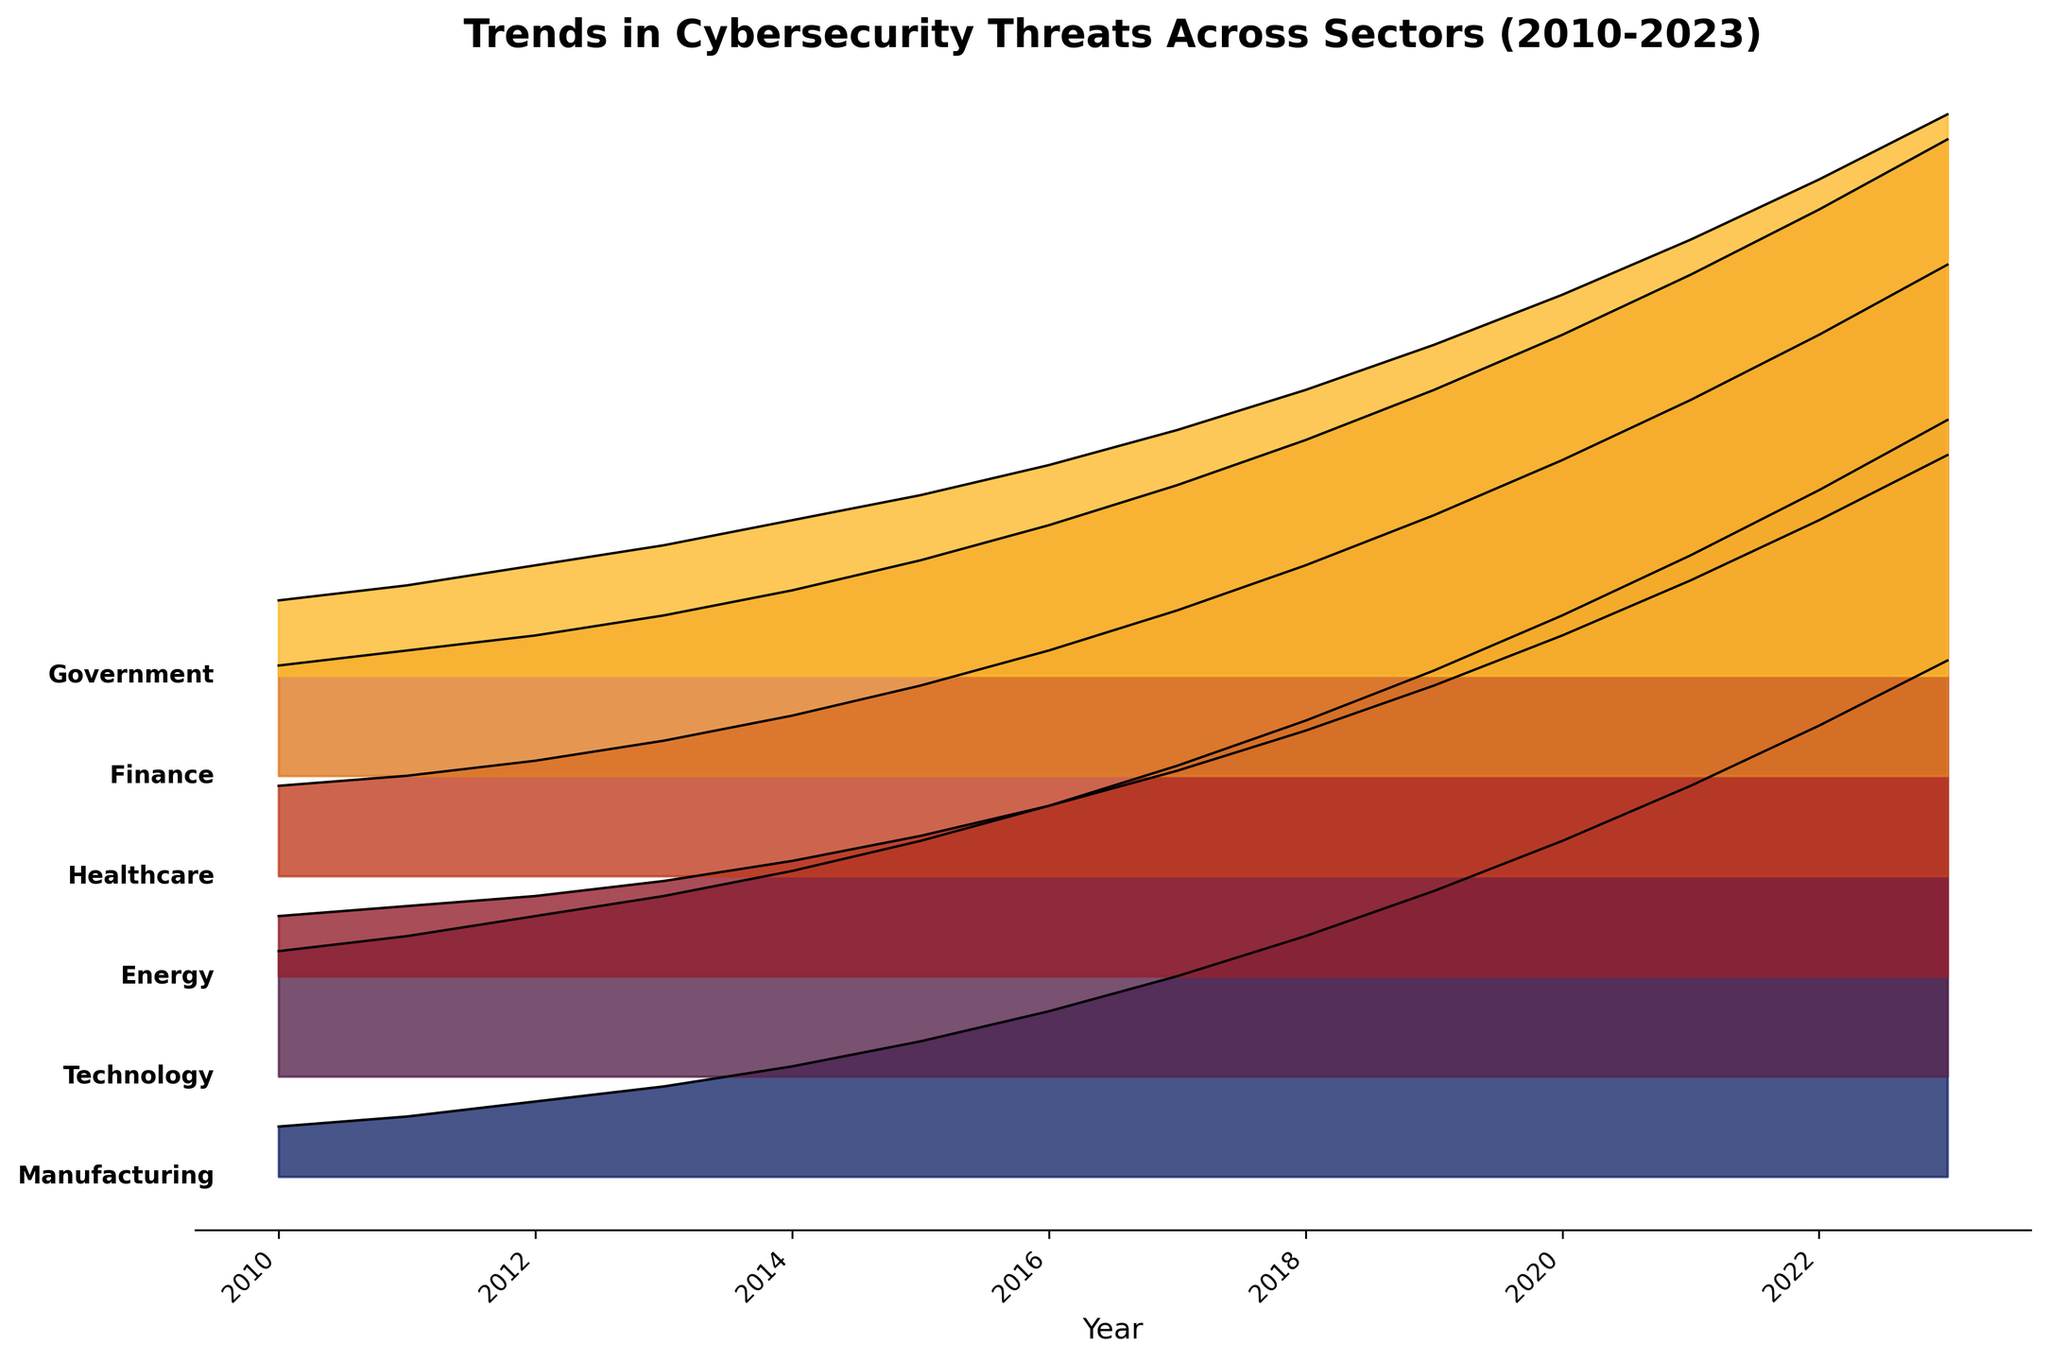What is the title of the plot? The title is usually the text written at the top of the plot. Here, the title is written in bold and larger font compared to the other text.
Answer: Trends in Cybersecurity Threats Across Sectors (2010-2023) Which sector experienced the highest number of cybersecurity threats in 2023? Look for the sector label at the top of the ridgeline plot for the year 2023 (the far-right side).
Answer: Technology How many years are represented in the plot? The x-axis of the plot typically shows the years. Check the range from the start year on the left to the end year on the right.
Answer: 14 In which year did finance overtake healthcare in the number of threats? Compare the lines for finance and healthcare. Look at the year when the finance line starts having a higher y-value than the healthcare line.
Answer: 2011 What is the difference in the number of threats between the energy and technology sectors in 2018? Locate the data points for both sectors in 2018, then subtract the number of threats in energy from the number of threats in technology. (71 - 49)
Answer: 22 Which sector showed the steepest increase in cybersecurity threats from 2015 to 2023? Compare the slopes of the lines between 2015 and 2023 for all sectors. The steepest slope indicates the biggest increase.
Answer: Technology What sectors are shown in the plot? The sectors are labeled on the plot, usually on one of the margins or alongside their respective lines.
Answer: Government, Finance, Healthcare, Energy, Technology, Manufacturing Which sector had the second-lowest number of threats in 2020? Compare the plotted values for 2020 for all sectors and find the second lowest value.
Answer: Manufacturing Between which two consecutive years did the finance sector see the largest jump in threats? Observe the finance sector's line and find the interval where the line's slope is the steepest. Compare differences between consecutive years.
Answer: 2020 and 2021 How does the number of threats in the manufacturing sector in 2015 compare to 2010? Find the data points for manufacturing in 2015 and 2010, respectively, and compare the values.
Answer: Higher in 2015 